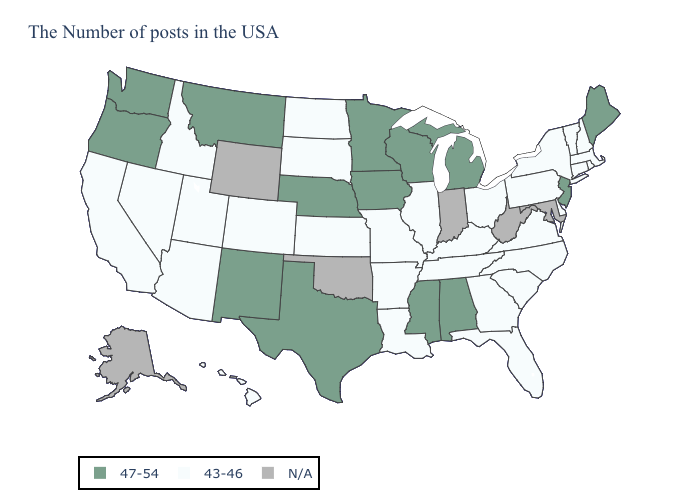Which states hav the highest value in the South?
Write a very short answer. Alabama, Mississippi, Texas. Name the states that have a value in the range 47-54?
Keep it brief. Maine, New Jersey, Michigan, Alabama, Wisconsin, Mississippi, Minnesota, Iowa, Nebraska, Texas, New Mexico, Montana, Washington, Oregon. What is the lowest value in the USA?
Short answer required. 43-46. How many symbols are there in the legend?
Quick response, please. 3. What is the value of Connecticut?
Be succinct. 43-46. Name the states that have a value in the range N/A?
Answer briefly. Maryland, West Virginia, Indiana, Oklahoma, Wyoming, Alaska. Name the states that have a value in the range 47-54?
Keep it brief. Maine, New Jersey, Michigan, Alabama, Wisconsin, Mississippi, Minnesota, Iowa, Nebraska, Texas, New Mexico, Montana, Washington, Oregon. Name the states that have a value in the range 47-54?
Short answer required. Maine, New Jersey, Michigan, Alabama, Wisconsin, Mississippi, Minnesota, Iowa, Nebraska, Texas, New Mexico, Montana, Washington, Oregon. Name the states that have a value in the range 43-46?
Give a very brief answer. Massachusetts, Rhode Island, New Hampshire, Vermont, Connecticut, New York, Delaware, Pennsylvania, Virginia, North Carolina, South Carolina, Ohio, Florida, Georgia, Kentucky, Tennessee, Illinois, Louisiana, Missouri, Arkansas, Kansas, South Dakota, North Dakota, Colorado, Utah, Arizona, Idaho, Nevada, California, Hawaii. Does Massachusetts have the lowest value in the USA?
Be succinct. Yes. Which states have the highest value in the USA?
Answer briefly. Maine, New Jersey, Michigan, Alabama, Wisconsin, Mississippi, Minnesota, Iowa, Nebraska, Texas, New Mexico, Montana, Washington, Oregon. What is the value of Tennessee?
Concise answer only. 43-46. 